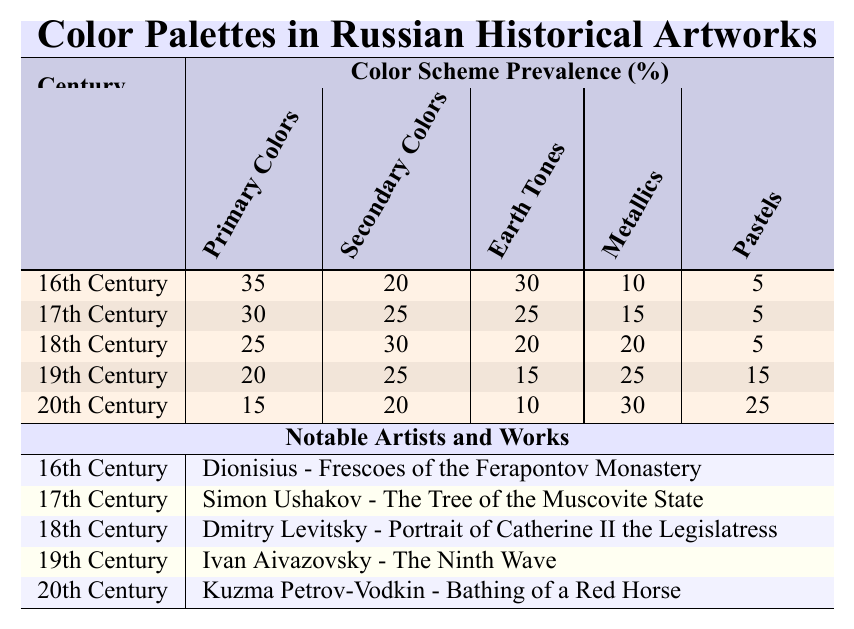What is the highest percentage of primary colors used in any century? The highest percentage of primary colors is 35%, which is recorded in the 16th Century.
Answer: 35% Which century saw a decrease in the use of earth tones compared to the previous century? The 19th Century recorded 15% earth tones, while the 18th Century had 20%, indicating a decrease of 5%.
Answer: 19th Century Was there any century that used more pastel colors than metallics? No, in every century metallic colors percentage was higher than pastel colors.
Answer: No What is the total percentage of secondary and earth tones used in the 20th Century? The 20th Century has 20% in secondary colors and 10% in earth tones. Adding these gives 20 + 10 = 30%.
Answer: 30% Which century had the least use of primary colors and who was a notable artist from that time? The 20th Century had the least use of primary colors at 15%. The notable artist was Kuzma Petrov-Vodkin.
Answer: 20th Century, Kuzma Petrov-Vodkin What is the average percentage of metallic colors across all centuries? Adding up all metallic values (10 + 15 + 20 + 25 + 30 = 100) and dividing by 5 gives an average of 20%.
Answer: 20% In which century were there more secondary colors compared to earth tones? The 17th Century had 25% secondary colors and 25% earth tones, while the 18th Century had 30% secondary and 20% earth tones, indicating both centuries had more secondary colors compared to their respective earth tones.
Answer: 18th Century How does the use of pastels change from the 16th Century to the 20th Century? The 16th Century had 5% pastels while the 20th Century had 25%, indicating an increase of 20%.
Answer: Increase of 20% What century used the least percentage of earth tones, and what was that percentage? The 20th Century used the least percentage of earth tones, which was 10%.
Answer: 10% Which century had the highest use of metallic colors and how much was that? The 20th Century had the highest use of metallic colors at 30%.
Answer: 30% 